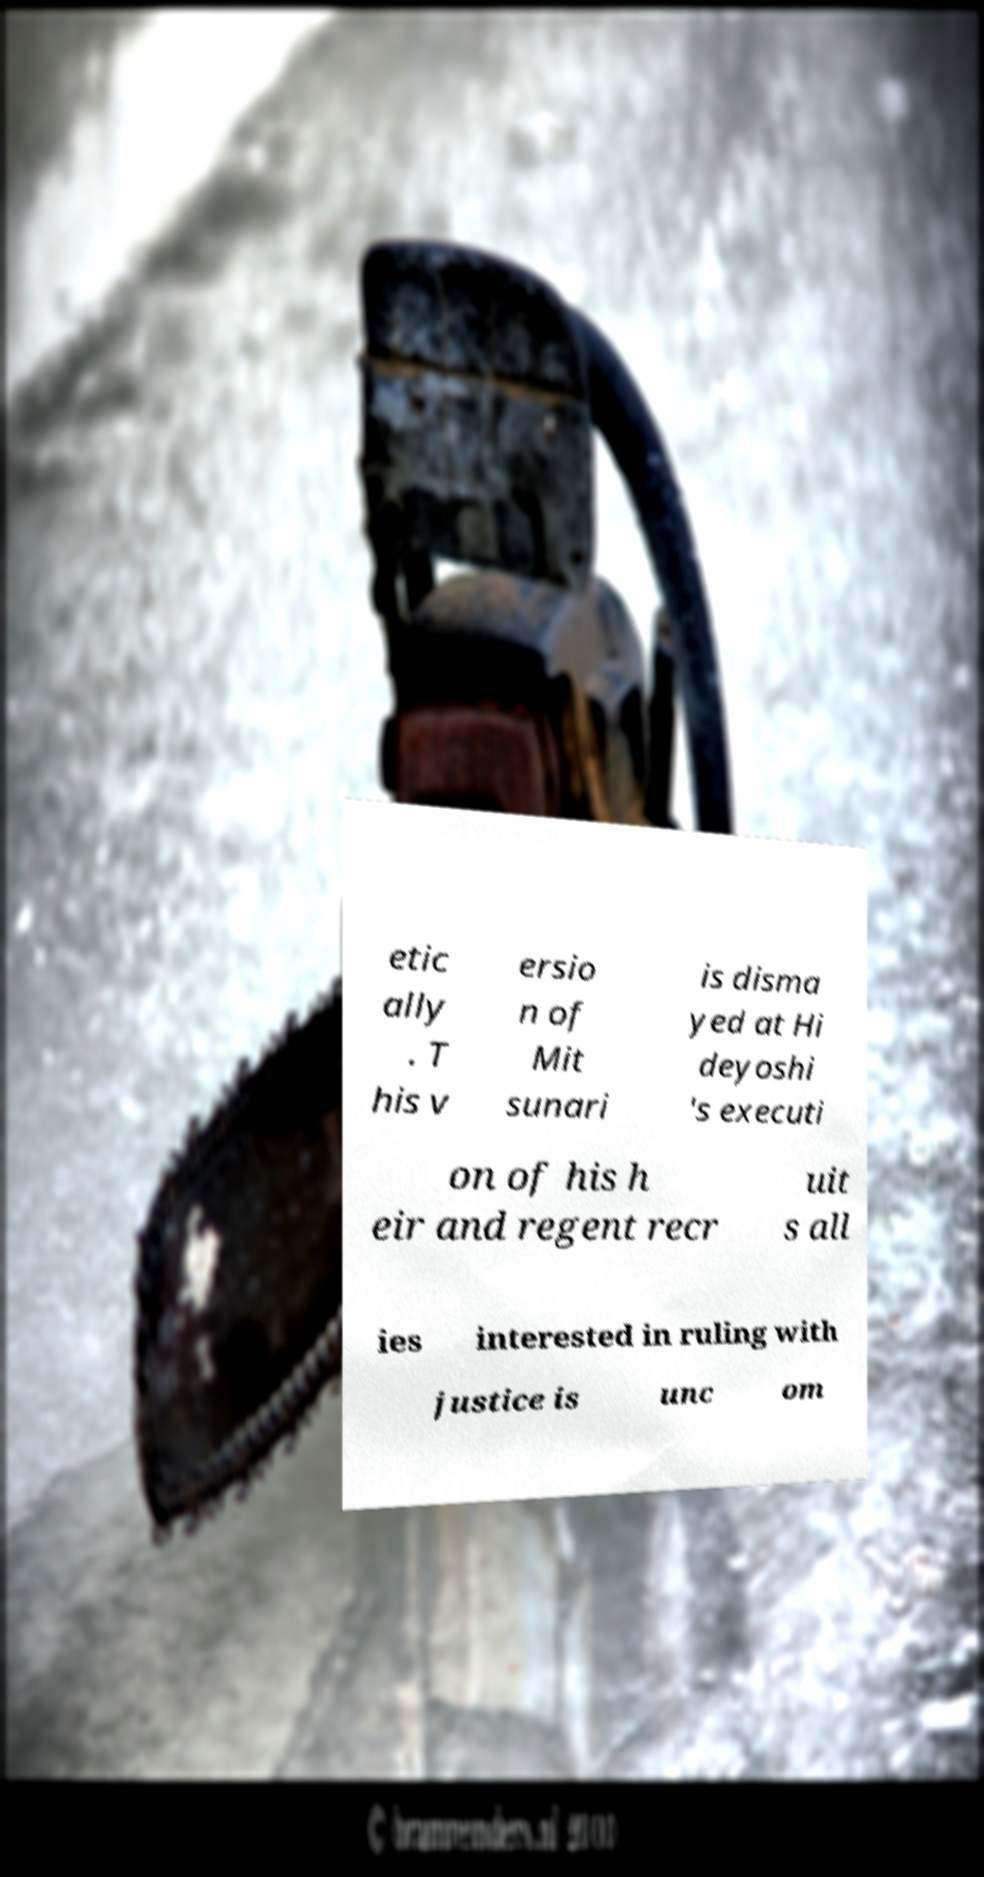For documentation purposes, I need the text within this image transcribed. Could you provide that? etic ally . T his v ersio n of Mit sunari is disma yed at Hi deyoshi 's executi on of his h eir and regent recr uit s all ies interested in ruling with justice is unc om 